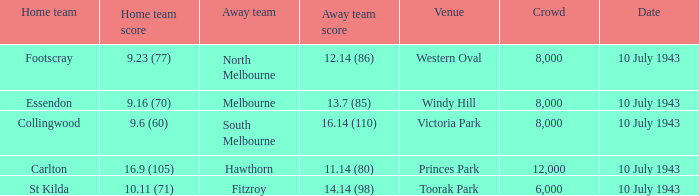When the Venue was victoria park, what was the Away team score? 16.14 (110). 